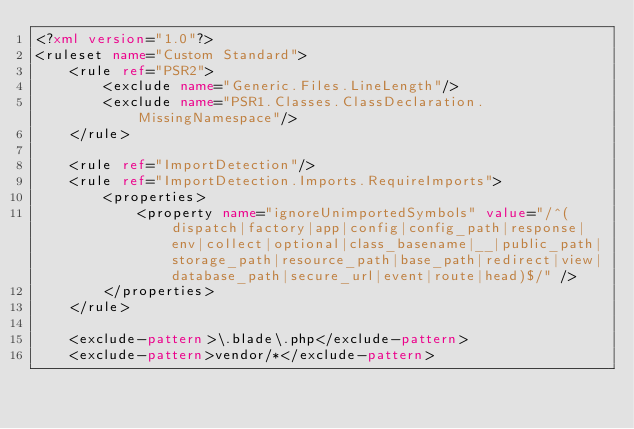<code> <loc_0><loc_0><loc_500><loc_500><_XML_><?xml version="1.0"?>
<ruleset name="Custom Standard">
    <rule ref="PSR2">
        <exclude name="Generic.Files.LineLength"/>
        <exclude name="PSR1.Classes.ClassDeclaration.MissingNamespace"/>
    </rule>

    <rule ref="ImportDetection"/>
    <rule ref="ImportDetection.Imports.RequireImports">
        <properties>
            <property name="ignoreUnimportedSymbols" value="/^(dispatch|factory|app|config|config_path|response|env|collect|optional|class_basename|__|public_path|storage_path|resource_path|base_path|redirect|view|database_path|secure_url|event|route|head)$/" />
        </properties>
    </rule>

    <exclude-pattern>\.blade\.php</exclude-pattern>
    <exclude-pattern>vendor/*</exclude-pattern></code> 